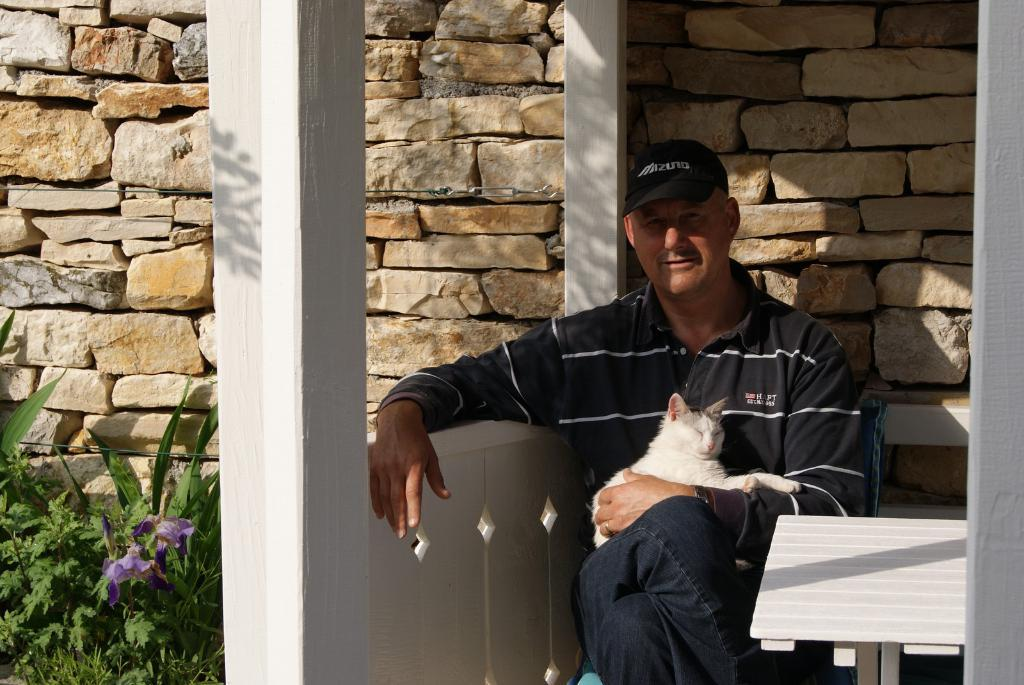What is the main subject of the image? There is a person in the image. What is the person wearing? The person is wearing a black shirt. What is the person doing in the image? The person is holding a pussy cat on his lap. What can be seen in the background of the image? There are plants and stones in the background of the image. What type of rice can be seen growing on the hill in the image? There is no hill or rice present in the image. What force is being applied to the pussy cat in the image? There is no force being applied to the pussy cat in the image; the person is simply holding it on his lap. 